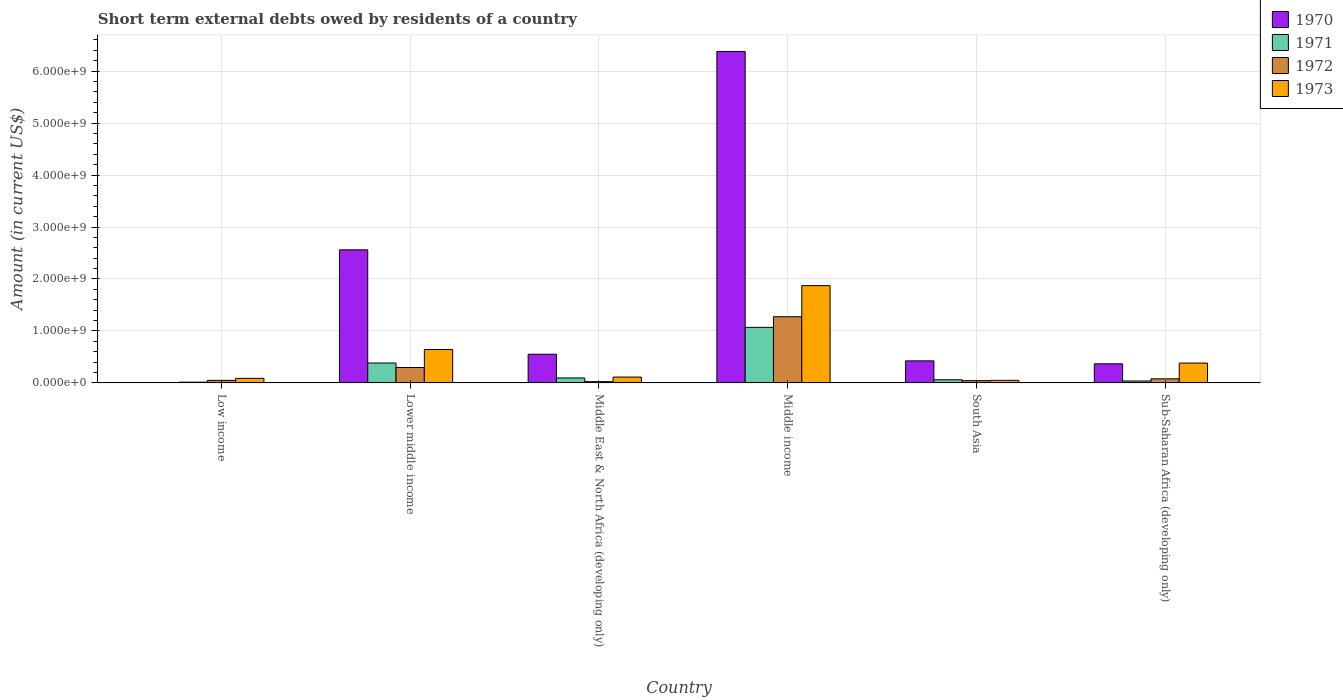How many different coloured bars are there?
Ensure brevity in your answer.  4. Are the number of bars per tick equal to the number of legend labels?
Offer a very short reply. No. What is the label of the 4th group of bars from the left?
Provide a succinct answer. Middle income. In how many cases, is the number of bars for a given country not equal to the number of legend labels?
Your response must be concise. 1. What is the amount of short-term external debts owed by residents in 1971 in South Asia?
Your answer should be compact. 6.10e+07. Across all countries, what is the maximum amount of short-term external debts owed by residents in 1972?
Make the answer very short. 1.27e+09. In which country was the amount of short-term external debts owed by residents in 1971 maximum?
Your answer should be compact. Middle income. What is the total amount of short-term external debts owed by residents in 1972 in the graph?
Give a very brief answer. 1.77e+09. What is the difference between the amount of short-term external debts owed by residents in 1972 in Lower middle income and that in Middle income?
Offer a terse response. -9.77e+08. What is the difference between the amount of short-term external debts owed by residents in 1971 in South Asia and the amount of short-term external debts owed by residents in 1972 in Lower middle income?
Offer a very short reply. -2.36e+08. What is the average amount of short-term external debts owed by residents in 1970 per country?
Give a very brief answer. 1.71e+09. What is the difference between the amount of short-term external debts owed by residents of/in 1972 and amount of short-term external debts owed by residents of/in 1970 in Middle income?
Give a very brief answer. -5.10e+09. What is the ratio of the amount of short-term external debts owed by residents in 1972 in Low income to that in Sub-Saharan Africa (developing only)?
Your answer should be very brief. 0.62. Is the difference between the amount of short-term external debts owed by residents in 1972 in Middle East & North Africa (developing only) and South Asia greater than the difference between the amount of short-term external debts owed by residents in 1970 in Middle East & North Africa (developing only) and South Asia?
Keep it short and to the point. No. What is the difference between the highest and the second highest amount of short-term external debts owed by residents in 1970?
Offer a terse response. 5.83e+09. What is the difference between the highest and the lowest amount of short-term external debts owed by residents in 1970?
Offer a very short reply. 6.38e+09. In how many countries, is the amount of short-term external debts owed by residents in 1970 greater than the average amount of short-term external debts owed by residents in 1970 taken over all countries?
Your response must be concise. 2. Is the sum of the amount of short-term external debts owed by residents in 1972 in Low income and Lower middle income greater than the maximum amount of short-term external debts owed by residents in 1973 across all countries?
Make the answer very short. No. Is it the case that in every country, the sum of the amount of short-term external debts owed by residents in 1970 and amount of short-term external debts owed by residents in 1973 is greater than the sum of amount of short-term external debts owed by residents in 1971 and amount of short-term external debts owed by residents in 1972?
Your answer should be very brief. No. How many bars are there?
Your answer should be very brief. 23. Are all the bars in the graph horizontal?
Make the answer very short. No. How many countries are there in the graph?
Your response must be concise. 6. What is the difference between two consecutive major ticks on the Y-axis?
Keep it short and to the point. 1.00e+09. Does the graph contain any zero values?
Offer a very short reply. Yes. Does the graph contain grids?
Provide a short and direct response. Yes. What is the title of the graph?
Provide a short and direct response. Short term external debts owed by residents of a country. Does "1961" appear as one of the legend labels in the graph?
Offer a very short reply. No. What is the Amount (in current US$) of 1971 in Low income?
Give a very brief answer. 1.54e+07. What is the Amount (in current US$) in 1972 in Low income?
Your response must be concise. 4.94e+07. What is the Amount (in current US$) in 1973 in Low income?
Keep it short and to the point. 8.84e+07. What is the Amount (in current US$) in 1970 in Lower middle income?
Ensure brevity in your answer.  2.56e+09. What is the Amount (in current US$) in 1971 in Lower middle income?
Your response must be concise. 3.83e+08. What is the Amount (in current US$) in 1972 in Lower middle income?
Keep it short and to the point. 2.97e+08. What is the Amount (in current US$) of 1973 in Lower middle income?
Ensure brevity in your answer.  6.43e+08. What is the Amount (in current US$) of 1970 in Middle East & North Africa (developing only)?
Give a very brief answer. 5.52e+08. What is the Amount (in current US$) in 1971 in Middle East & North Africa (developing only)?
Offer a terse response. 9.60e+07. What is the Amount (in current US$) in 1972 in Middle East & North Africa (developing only)?
Offer a terse response. 2.50e+07. What is the Amount (in current US$) of 1973 in Middle East & North Africa (developing only)?
Provide a succinct answer. 1.13e+08. What is the Amount (in current US$) of 1970 in Middle income?
Make the answer very short. 6.38e+09. What is the Amount (in current US$) in 1971 in Middle income?
Your answer should be very brief. 1.07e+09. What is the Amount (in current US$) of 1972 in Middle income?
Provide a succinct answer. 1.27e+09. What is the Amount (in current US$) of 1973 in Middle income?
Ensure brevity in your answer.  1.87e+09. What is the Amount (in current US$) in 1970 in South Asia?
Give a very brief answer. 4.25e+08. What is the Amount (in current US$) of 1971 in South Asia?
Ensure brevity in your answer.  6.10e+07. What is the Amount (in current US$) of 1972 in South Asia?
Your response must be concise. 4.40e+07. What is the Amount (in current US$) in 1970 in Sub-Saharan Africa (developing only)?
Ensure brevity in your answer.  3.68e+08. What is the Amount (in current US$) in 1971 in Sub-Saharan Africa (developing only)?
Your response must be concise. 3.78e+07. What is the Amount (in current US$) in 1972 in Sub-Saharan Africa (developing only)?
Provide a short and direct response. 7.93e+07. What is the Amount (in current US$) of 1973 in Sub-Saharan Africa (developing only)?
Offer a terse response. 3.82e+08. Across all countries, what is the maximum Amount (in current US$) of 1970?
Ensure brevity in your answer.  6.38e+09. Across all countries, what is the maximum Amount (in current US$) in 1971?
Keep it short and to the point. 1.07e+09. Across all countries, what is the maximum Amount (in current US$) in 1972?
Ensure brevity in your answer.  1.27e+09. Across all countries, what is the maximum Amount (in current US$) in 1973?
Give a very brief answer. 1.87e+09. Across all countries, what is the minimum Amount (in current US$) of 1971?
Your answer should be compact. 1.54e+07. Across all countries, what is the minimum Amount (in current US$) of 1972?
Your answer should be compact. 2.50e+07. Across all countries, what is the minimum Amount (in current US$) of 1973?
Keep it short and to the point. 5.00e+07. What is the total Amount (in current US$) in 1970 in the graph?
Your answer should be very brief. 1.03e+1. What is the total Amount (in current US$) of 1971 in the graph?
Make the answer very short. 1.66e+09. What is the total Amount (in current US$) of 1972 in the graph?
Ensure brevity in your answer.  1.77e+09. What is the total Amount (in current US$) of 1973 in the graph?
Provide a short and direct response. 3.15e+09. What is the difference between the Amount (in current US$) in 1971 in Low income and that in Lower middle income?
Your response must be concise. -3.68e+08. What is the difference between the Amount (in current US$) in 1972 in Low income and that in Lower middle income?
Ensure brevity in your answer.  -2.47e+08. What is the difference between the Amount (in current US$) in 1973 in Low income and that in Lower middle income?
Your response must be concise. -5.54e+08. What is the difference between the Amount (in current US$) in 1971 in Low income and that in Middle East & North Africa (developing only)?
Your answer should be very brief. -8.06e+07. What is the difference between the Amount (in current US$) in 1972 in Low income and that in Middle East & North Africa (developing only)?
Your answer should be compact. 2.44e+07. What is the difference between the Amount (in current US$) in 1973 in Low income and that in Middle East & North Africa (developing only)?
Provide a short and direct response. -2.46e+07. What is the difference between the Amount (in current US$) in 1971 in Low income and that in Middle income?
Your answer should be very brief. -1.05e+09. What is the difference between the Amount (in current US$) of 1972 in Low income and that in Middle income?
Make the answer very short. -1.22e+09. What is the difference between the Amount (in current US$) of 1973 in Low income and that in Middle income?
Your answer should be compact. -1.78e+09. What is the difference between the Amount (in current US$) in 1971 in Low income and that in South Asia?
Make the answer very short. -4.56e+07. What is the difference between the Amount (in current US$) of 1972 in Low income and that in South Asia?
Make the answer very short. 5.35e+06. What is the difference between the Amount (in current US$) of 1973 in Low income and that in South Asia?
Provide a succinct answer. 3.84e+07. What is the difference between the Amount (in current US$) of 1971 in Low income and that in Sub-Saharan Africa (developing only)?
Keep it short and to the point. -2.25e+07. What is the difference between the Amount (in current US$) of 1972 in Low income and that in Sub-Saharan Africa (developing only)?
Provide a short and direct response. -3.00e+07. What is the difference between the Amount (in current US$) in 1973 in Low income and that in Sub-Saharan Africa (developing only)?
Your answer should be compact. -2.94e+08. What is the difference between the Amount (in current US$) in 1970 in Lower middle income and that in Middle East & North Africa (developing only)?
Offer a terse response. 2.01e+09. What is the difference between the Amount (in current US$) in 1971 in Lower middle income and that in Middle East & North Africa (developing only)?
Make the answer very short. 2.87e+08. What is the difference between the Amount (in current US$) of 1972 in Lower middle income and that in Middle East & North Africa (developing only)?
Keep it short and to the point. 2.72e+08. What is the difference between the Amount (in current US$) in 1973 in Lower middle income and that in Middle East & North Africa (developing only)?
Your response must be concise. 5.30e+08. What is the difference between the Amount (in current US$) in 1970 in Lower middle income and that in Middle income?
Offer a very short reply. -3.82e+09. What is the difference between the Amount (in current US$) of 1971 in Lower middle income and that in Middle income?
Ensure brevity in your answer.  -6.86e+08. What is the difference between the Amount (in current US$) in 1972 in Lower middle income and that in Middle income?
Provide a succinct answer. -9.77e+08. What is the difference between the Amount (in current US$) in 1973 in Lower middle income and that in Middle income?
Keep it short and to the point. -1.23e+09. What is the difference between the Amount (in current US$) of 1970 in Lower middle income and that in South Asia?
Your answer should be very brief. 2.14e+09. What is the difference between the Amount (in current US$) of 1971 in Lower middle income and that in South Asia?
Keep it short and to the point. 3.22e+08. What is the difference between the Amount (in current US$) in 1972 in Lower middle income and that in South Asia?
Your response must be concise. 2.53e+08. What is the difference between the Amount (in current US$) of 1973 in Lower middle income and that in South Asia?
Give a very brief answer. 5.93e+08. What is the difference between the Amount (in current US$) in 1970 in Lower middle income and that in Sub-Saharan Africa (developing only)?
Make the answer very short. 2.19e+09. What is the difference between the Amount (in current US$) of 1971 in Lower middle income and that in Sub-Saharan Africa (developing only)?
Give a very brief answer. 3.46e+08. What is the difference between the Amount (in current US$) of 1972 in Lower middle income and that in Sub-Saharan Africa (developing only)?
Your answer should be very brief. 2.18e+08. What is the difference between the Amount (in current US$) in 1973 in Lower middle income and that in Sub-Saharan Africa (developing only)?
Ensure brevity in your answer.  2.61e+08. What is the difference between the Amount (in current US$) of 1970 in Middle East & North Africa (developing only) and that in Middle income?
Offer a very short reply. -5.83e+09. What is the difference between the Amount (in current US$) of 1971 in Middle East & North Africa (developing only) and that in Middle income?
Make the answer very short. -9.73e+08. What is the difference between the Amount (in current US$) in 1972 in Middle East & North Africa (developing only) and that in Middle income?
Provide a succinct answer. -1.25e+09. What is the difference between the Amount (in current US$) in 1973 in Middle East & North Africa (developing only) and that in Middle income?
Your answer should be compact. -1.76e+09. What is the difference between the Amount (in current US$) in 1970 in Middle East & North Africa (developing only) and that in South Asia?
Provide a succinct answer. 1.27e+08. What is the difference between the Amount (in current US$) of 1971 in Middle East & North Africa (developing only) and that in South Asia?
Ensure brevity in your answer.  3.50e+07. What is the difference between the Amount (in current US$) of 1972 in Middle East & North Africa (developing only) and that in South Asia?
Your response must be concise. -1.90e+07. What is the difference between the Amount (in current US$) of 1973 in Middle East & North Africa (developing only) and that in South Asia?
Provide a succinct answer. 6.30e+07. What is the difference between the Amount (in current US$) of 1970 in Middle East & North Africa (developing only) and that in Sub-Saharan Africa (developing only)?
Your answer should be compact. 1.84e+08. What is the difference between the Amount (in current US$) in 1971 in Middle East & North Africa (developing only) and that in Sub-Saharan Africa (developing only)?
Your answer should be compact. 5.82e+07. What is the difference between the Amount (in current US$) of 1972 in Middle East & North Africa (developing only) and that in Sub-Saharan Africa (developing only)?
Your answer should be very brief. -5.43e+07. What is the difference between the Amount (in current US$) of 1973 in Middle East & North Africa (developing only) and that in Sub-Saharan Africa (developing only)?
Your response must be concise. -2.69e+08. What is the difference between the Amount (in current US$) in 1970 in Middle income and that in South Asia?
Offer a terse response. 5.95e+09. What is the difference between the Amount (in current US$) in 1971 in Middle income and that in South Asia?
Ensure brevity in your answer.  1.01e+09. What is the difference between the Amount (in current US$) in 1972 in Middle income and that in South Asia?
Your response must be concise. 1.23e+09. What is the difference between the Amount (in current US$) of 1973 in Middle income and that in South Asia?
Make the answer very short. 1.82e+09. What is the difference between the Amount (in current US$) in 1970 in Middle income and that in Sub-Saharan Africa (developing only)?
Offer a terse response. 6.01e+09. What is the difference between the Amount (in current US$) in 1971 in Middle income and that in Sub-Saharan Africa (developing only)?
Ensure brevity in your answer.  1.03e+09. What is the difference between the Amount (in current US$) in 1972 in Middle income and that in Sub-Saharan Africa (developing only)?
Your answer should be compact. 1.19e+09. What is the difference between the Amount (in current US$) of 1973 in Middle income and that in Sub-Saharan Africa (developing only)?
Give a very brief answer. 1.49e+09. What is the difference between the Amount (in current US$) of 1970 in South Asia and that in Sub-Saharan Africa (developing only)?
Give a very brief answer. 5.71e+07. What is the difference between the Amount (in current US$) in 1971 in South Asia and that in Sub-Saharan Africa (developing only)?
Your answer should be very brief. 2.32e+07. What is the difference between the Amount (in current US$) of 1972 in South Asia and that in Sub-Saharan Africa (developing only)?
Offer a terse response. -3.53e+07. What is the difference between the Amount (in current US$) in 1973 in South Asia and that in Sub-Saharan Africa (developing only)?
Give a very brief answer. -3.32e+08. What is the difference between the Amount (in current US$) of 1971 in Low income and the Amount (in current US$) of 1972 in Lower middle income?
Make the answer very short. -2.81e+08. What is the difference between the Amount (in current US$) in 1971 in Low income and the Amount (in current US$) in 1973 in Lower middle income?
Give a very brief answer. -6.27e+08. What is the difference between the Amount (in current US$) in 1972 in Low income and the Amount (in current US$) in 1973 in Lower middle income?
Offer a very short reply. -5.93e+08. What is the difference between the Amount (in current US$) of 1971 in Low income and the Amount (in current US$) of 1972 in Middle East & North Africa (developing only)?
Ensure brevity in your answer.  -9.65e+06. What is the difference between the Amount (in current US$) in 1971 in Low income and the Amount (in current US$) in 1973 in Middle East & North Africa (developing only)?
Your response must be concise. -9.76e+07. What is the difference between the Amount (in current US$) in 1972 in Low income and the Amount (in current US$) in 1973 in Middle East & North Africa (developing only)?
Provide a succinct answer. -6.36e+07. What is the difference between the Amount (in current US$) in 1971 in Low income and the Amount (in current US$) in 1972 in Middle income?
Provide a succinct answer. -1.26e+09. What is the difference between the Amount (in current US$) of 1971 in Low income and the Amount (in current US$) of 1973 in Middle income?
Provide a short and direct response. -1.86e+09. What is the difference between the Amount (in current US$) of 1972 in Low income and the Amount (in current US$) of 1973 in Middle income?
Your answer should be very brief. -1.82e+09. What is the difference between the Amount (in current US$) in 1971 in Low income and the Amount (in current US$) in 1972 in South Asia?
Your response must be concise. -2.86e+07. What is the difference between the Amount (in current US$) of 1971 in Low income and the Amount (in current US$) of 1973 in South Asia?
Ensure brevity in your answer.  -3.46e+07. What is the difference between the Amount (in current US$) in 1972 in Low income and the Amount (in current US$) in 1973 in South Asia?
Your response must be concise. -6.46e+05. What is the difference between the Amount (in current US$) in 1971 in Low income and the Amount (in current US$) in 1972 in Sub-Saharan Africa (developing only)?
Offer a very short reply. -6.40e+07. What is the difference between the Amount (in current US$) of 1971 in Low income and the Amount (in current US$) of 1973 in Sub-Saharan Africa (developing only)?
Your answer should be very brief. -3.67e+08. What is the difference between the Amount (in current US$) of 1972 in Low income and the Amount (in current US$) of 1973 in Sub-Saharan Africa (developing only)?
Give a very brief answer. -3.33e+08. What is the difference between the Amount (in current US$) of 1970 in Lower middle income and the Amount (in current US$) of 1971 in Middle East & North Africa (developing only)?
Keep it short and to the point. 2.46e+09. What is the difference between the Amount (in current US$) in 1970 in Lower middle income and the Amount (in current US$) in 1972 in Middle East & North Africa (developing only)?
Offer a terse response. 2.54e+09. What is the difference between the Amount (in current US$) of 1970 in Lower middle income and the Amount (in current US$) of 1973 in Middle East & North Africa (developing only)?
Make the answer very short. 2.45e+09. What is the difference between the Amount (in current US$) in 1971 in Lower middle income and the Amount (in current US$) in 1972 in Middle East & North Africa (developing only)?
Keep it short and to the point. 3.58e+08. What is the difference between the Amount (in current US$) in 1971 in Lower middle income and the Amount (in current US$) in 1973 in Middle East & North Africa (developing only)?
Offer a terse response. 2.70e+08. What is the difference between the Amount (in current US$) in 1972 in Lower middle income and the Amount (in current US$) in 1973 in Middle East & North Africa (developing only)?
Make the answer very short. 1.84e+08. What is the difference between the Amount (in current US$) in 1970 in Lower middle income and the Amount (in current US$) in 1971 in Middle income?
Make the answer very short. 1.49e+09. What is the difference between the Amount (in current US$) in 1970 in Lower middle income and the Amount (in current US$) in 1972 in Middle income?
Your answer should be very brief. 1.29e+09. What is the difference between the Amount (in current US$) of 1970 in Lower middle income and the Amount (in current US$) of 1973 in Middle income?
Provide a short and direct response. 6.89e+08. What is the difference between the Amount (in current US$) in 1971 in Lower middle income and the Amount (in current US$) in 1972 in Middle income?
Provide a succinct answer. -8.91e+08. What is the difference between the Amount (in current US$) in 1971 in Lower middle income and the Amount (in current US$) in 1973 in Middle income?
Provide a short and direct response. -1.49e+09. What is the difference between the Amount (in current US$) in 1972 in Lower middle income and the Amount (in current US$) in 1973 in Middle income?
Keep it short and to the point. -1.58e+09. What is the difference between the Amount (in current US$) of 1970 in Lower middle income and the Amount (in current US$) of 1971 in South Asia?
Offer a very short reply. 2.50e+09. What is the difference between the Amount (in current US$) of 1970 in Lower middle income and the Amount (in current US$) of 1972 in South Asia?
Offer a very short reply. 2.52e+09. What is the difference between the Amount (in current US$) of 1970 in Lower middle income and the Amount (in current US$) of 1973 in South Asia?
Keep it short and to the point. 2.51e+09. What is the difference between the Amount (in current US$) in 1971 in Lower middle income and the Amount (in current US$) in 1972 in South Asia?
Provide a succinct answer. 3.39e+08. What is the difference between the Amount (in current US$) of 1971 in Lower middle income and the Amount (in current US$) of 1973 in South Asia?
Your answer should be compact. 3.33e+08. What is the difference between the Amount (in current US$) of 1972 in Lower middle income and the Amount (in current US$) of 1973 in South Asia?
Provide a succinct answer. 2.47e+08. What is the difference between the Amount (in current US$) in 1970 in Lower middle income and the Amount (in current US$) in 1971 in Sub-Saharan Africa (developing only)?
Provide a succinct answer. 2.52e+09. What is the difference between the Amount (in current US$) of 1970 in Lower middle income and the Amount (in current US$) of 1972 in Sub-Saharan Africa (developing only)?
Ensure brevity in your answer.  2.48e+09. What is the difference between the Amount (in current US$) of 1970 in Lower middle income and the Amount (in current US$) of 1973 in Sub-Saharan Africa (developing only)?
Offer a very short reply. 2.18e+09. What is the difference between the Amount (in current US$) of 1971 in Lower middle income and the Amount (in current US$) of 1972 in Sub-Saharan Africa (developing only)?
Your answer should be compact. 3.04e+08. What is the difference between the Amount (in current US$) in 1971 in Lower middle income and the Amount (in current US$) in 1973 in Sub-Saharan Africa (developing only)?
Keep it short and to the point. 1.02e+06. What is the difference between the Amount (in current US$) of 1972 in Lower middle income and the Amount (in current US$) of 1973 in Sub-Saharan Africa (developing only)?
Offer a terse response. -8.55e+07. What is the difference between the Amount (in current US$) in 1970 in Middle East & North Africa (developing only) and the Amount (in current US$) in 1971 in Middle income?
Make the answer very short. -5.17e+08. What is the difference between the Amount (in current US$) in 1970 in Middle East & North Africa (developing only) and the Amount (in current US$) in 1972 in Middle income?
Provide a succinct answer. -7.22e+08. What is the difference between the Amount (in current US$) in 1970 in Middle East & North Africa (developing only) and the Amount (in current US$) in 1973 in Middle income?
Your answer should be very brief. -1.32e+09. What is the difference between the Amount (in current US$) in 1971 in Middle East & North Africa (developing only) and the Amount (in current US$) in 1972 in Middle income?
Offer a terse response. -1.18e+09. What is the difference between the Amount (in current US$) of 1971 in Middle East & North Africa (developing only) and the Amount (in current US$) of 1973 in Middle income?
Make the answer very short. -1.78e+09. What is the difference between the Amount (in current US$) in 1972 in Middle East & North Africa (developing only) and the Amount (in current US$) in 1973 in Middle income?
Give a very brief answer. -1.85e+09. What is the difference between the Amount (in current US$) in 1970 in Middle East & North Africa (developing only) and the Amount (in current US$) in 1971 in South Asia?
Keep it short and to the point. 4.91e+08. What is the difference between the Amount (in current US$) in 1970 in Middle East & North Africa (developing only) and the Amount (in current US$) in 1972 in South Asia?
Give a very brief answer. 5.08e+08. What is the difference between the Amount (in current US$) in 1970 in Middle East & North Africa (developing only) and the Amount (in current US$) in 1973 in South Asia?
Provide a short and direct response. 5.02e+08. What is the difference between the Amount (in current US$) in 1971 in Middle East & North Africa (developing only) and the Amount (in current US$) in 1972 in South Asia?
Provide a short and direct response. 5.20e+07. What is the difference between the Amount (in current US$) of 1971 in Middle East & North Africa (developing only) and the Amount (in current US$) of 1973 in South Asia?
Offer a terse response. 4.60e+07. What is the difference between the Amount (in current US$) in 1972 in Middle East & North Africa (developing only) and the Amount (in current US$) in 1973 in South Asia?
Provide a succinct answer. -2.50e+07. What is the difference between the Amount (in current US$) in 1970 in Middle East & North Africa (developing only) and the Amount (in current US$) in 1971 in Sub-Saharan Africa (developing only)?
Provide a short and direct response. 5.14e+08. What is the difference between the Amount (in current US$) of 1970 in Middle East & North Africa (developing only) and the Amount (in current US$) of 1972 in Sub-Saharan Africa (developing only)?
Provide a short and direct response. 4.73e+08. What is the difference between the Amount (in current US$) in 1970 in Middle East & North Africa (developing only) and the Amount (in current US$) in 1973 in Sub-Saharan Africa (developing only)?
Your response must be concise. 1.70e+08. What is the difference between the Amount (in current US$) in 1971 in Middle East & North Africa (developing only) and the Amount (in current US$) in 1972 in Sub-Saharan Africa (developing only)?
Offer a terse response. 1.67e+07. What is the difference between the Amount (in current US$) of 1971 in Middle East & North Africa (developing only) and the Amount (in current US$) of 1973 in Sub-Saharan Africa (developing only)?
Offer a terse response. -2.86e+08. What is the difference between the Amount (in current US$) in 1972 in Middle East & North Africa (developing only) and the Amount (in current US$) in 1973 in Sub-Saharan Africa (developing only)?
Keep it short and to the point. -3.57e+08. What is the difference between the Amount (in current US$) in 1970 in Middle income and the Amount (in current US$) in 1971 in South Asia?
Your response must be concise. 6.32e+09. What is the difference between the Amount (in current US$) in 1970 in Middle income and the Amount (in current US$) in 1972 in South Asia?
Provide a short and direct response. 6.33e+09. What is the difference between the Amount (in current US$) in 1970 in Middle income and the Amount (in current US$) in 1973 in South Asia?
Your response must be concise. 6.33e+09. What is the difference between the Amount (in current US$) of 1971 in Middle income and the Amount (in current US$) of 1972 in South Asia?
Give a very brief answer. 1.03e+09. What is the difference between the Amount (in current US$) of 1971 in Middle income and the Amount (in current US$) of 1973 in South Asia?
Give a very brief answer. 1.02e+09. What is the difference between the Amount (in current US$) of 1972 in Middle income and the Amount (in current US$) of 1973 in South Asia?
Offer a very short reply. 1.22e+09. What is the difference between the Amount (in current US$) in 1970 in Middle income and the Amount (in current US$) in 1971 in Sub-Saharan Africa (developing only)?
Your answer should be compact. 6.34e+09. What is the difference between the Amount (in current US$) of 1970 in Middle income and the Amount (in current US$) of 1972 in Sub-Saharan Africa (developing only)?
Provide a short and direct response. 6.30e+09. What is the difference between the Amount (in current US$) in 1970 in Middle income and the Amount (in current US$) in 1973 in Sub-Saharan Africa (developing only)?
Ensure brevity in your answer.  6.00e+09. What is the difference between the Amount (in current US$) in 1971 in Middle income and the Amount (in current US$) in 1972 in Sub-Saharan Africa (developing only)?
Provide a short and direct response. 9.90e+08. What is the difference between the Amount (in current US$) of 1971 in Middle income and the Amount (in current US$) of 1973 in Sub-Saharan Africa (developing only)?
Your response must be concise. 6.87e+08. What is the difference between the Amount (in current US$) in 1972 in Middle income and the Amount (in current US$) in 1973 in Sub-Saharan Africa (developing only)?
Ensure brevity in your answer.  8.92e+08. What is the difference between the Amount (in current US$) in 1970 in South Asia and the Amount (in current US$) in 1971 in Sub-Saharan Africa (developing only)?
Your answer should be compact. 3.87e+08. What is the difference between the Amount (in current US$) of 1970 in South Asia and the Amount (in current US$) of 1972 in Sub-Saharan Africa (developing only)?
Offer a very short reply. 3.46e+08. What is the difference between the Amount (in current US$) in 1970 in South Asia and the Amount (in current US$) in 1973 in Sub-Saharan Africa (developing only)?
Your answer should be compact. 4.27e+07. What is the difference between the Amount (in current US$) of 1971 in South Asia and the Amount (in current US$) of 1972 in Sub-Saharan Africa (developing only)?
Offer a very short reply. -1.83e+07. What is the difference between the Amount (in current US$) of 1971 in South Asia and the Amount (in current US$) of 1973 in Sub-Saharan Africa (developing only)?
Make the answer very short. -3.21e+08. What is the difference between the Amount (in current US$) in 1972 in South Asia and the Amount (in current US$) in 1973 in Sub-Saharan Africa (developing only)?
Your response must be concise. -3.38e+08. What is the average Amount (in current US$) in 1970 per country?
Make the answer very short. 1.71e+09. What is the average Amount (in current US$) in 1971 per country?
Ensure brevity in your answer.  2.77e+08. What is the average Amount (in current US$) in 1972 per country?
Make the answer very short. 2.95e+08. What is the average Amount (in current US$) of 1973 per country?
Your answer should be very brief. 5.25e+08. What is the difference between the Amount (in current US$) of 1971 and Amount (in current US$) of 1972 in Low income?
Offer a terse response. -3.40e+07. What is the difference between the Amount (in current US$) in 1971 and Amount (in current US$) in 1973 in Low income?
Your answer should be very brief. -7.30e+07. What is the difference between the Amount (in current US$) in 1972 and Amount (in current US$) in 1973 in Low income?
Your answer should be compact. -3.90e+07. What is the difference between the Amount (in current US$) of 1970 and Amount (in current US$) of 1971 in Lower middle income?
Offer a very short reply. 2.18e+09. What is the difference between the Amount (in current US$) of 1970 and Amount (in current US$) of 1972 in Lower middle income?
Provide a short and direct response. 2.26e+09. What is the difference between the Amount (in current US$) of 1970 and Amount (in current US$) of 1973 in Lower middle income?
Provide a short and direct response. 1.92e+09. What is the difference between the Amount (in current US$) of 1971 and Amount (in current US$) of 1972 in Lower middle income?
Your answer should be compact. 8.65e+07. What is the difference between the Amount (in current US$) in 1971 and Amount (in current US$) in 1973 in Lower middle income?
Your answer should be very brief. -2.60e+08. What is the difference between the Amount (in current US$) in 1972 and Amount (in current US$) in 1973 in Lower middle income?
Keep it short and to the point. -3.46e+08. What is the difference between the Amount (in current US$) of 1970 and Amount (in current US$) of 1971 in Middle East & North Africa (developing only)?
Offer a very short reply. 4.56e+08. What is the difference between the Amount (in current US$) in 1970 and Amount (in current US$) in 1972 in Middle East & North Africa (developing only)?
Offer a terse response. 5.27e+08. What is the difference between the Amount (in current US$) in 1970 and Amount (in current US$) in 1973 in Middle East & North Africa (developing only)?
Ensure brevity in your answer.  4.39e+08. What is the difference between the Amount (in current US$) in 1971 and Amount (in current US$) in 1972 in Middle East & North Africa (developing only)?
Provide a succinct answer. 7.10e+07. What is the difference between the Amount (in current US$) in 1971 and Amount (in current US$) in 1973 in Middle East & North Africa (developing only)?
Make the answer very short. -1.70e+07. What is the difference between the Amount (in current US$) of 1972 and Amount (in current US$) of 1973 in Middle East & North Africa (developing only)?
Give a very brief answer. -8.80e+07. What is the difference between the Amount (in current US$) in 1970 and Amount (in current US$) in 1971 in Middle income?
Ensure brevity in your answer.  5.31e+09. What is the difference between the Amount (in current US$) of 1970 and Amount (in current US$) of 1972 in Middle income?
Your response must be concise. 5.10e+09. What is the difference between the Amount (in current US$) in 1970 and Amount (in current US$) in 1973 in Middle income?
Make the answer very short. 4.51e+09. What is the difference between the Amount (in current US$) of 1971 and Amount (in current US$) of 1972 in Middle income?
Offer a very short reply. -2.05e+08. What is the difference between the Amount (in current US$) of 1971 and Amount (in current US$) of 1973 in Middle income?
Offer a very short reply. -8.03e+08. What is the difference between the Amount (in current US$) of 1972 and Amount (in current US$) of 1973 in Middle income?
Your response must be concise. -5.98e+08. What is the difference between the Amount (in current US$) of 1970 and Amount (in current US$) of 1971 in South Asia?
Provide a succinct answer. 3.64e+08. What is the difference between the Amount (in current US$) of 1970 and Amount (in current US$) of 1972 in South Asia?
Offer a very short reply. 3.81e+08. What is the difference between the Amount (in current US$) in 1970 and Amount (in current US$) in 1973 in South Asia?
Make the answer very short. 3.75e+08. What is the difference between the Amount (in current US$) in 1971 and Amount (in current US$) in 1972 in South Asia?
Your answer should be very brief. 1.70e+07. What is the difference between the Amount (in current US$) of 1971 and Amount (in current US$) of 1973 in South Asia?
Keep it short and to the point. 1.10e+07. What is the difference between the Amount (in current US$) of 1972 and Amount (in current US$) of 1973 in South Asia?
Make the answer very short. -6.00e+06. What is the difference between the Amount (in current US$) of 1970 and Amount (in current US$) of 1971 in Sub-Saharan Africa (developing only)?
Provide a short and direct response. 3.30e+08. What is the difference between the Amount (in current US$) of 1970 and Amount (in current US$) of 1972 in Sub-Saharan Africa (developing only)?
Ensure brevity in your answer.  2.89e+08. What is the difference between the Amount (in current US$) of 1970 and Amount (in current US$) of 1973 in Sub-Saharan Africa (developing only)?
Offer a very short reply. -1.44e+07. What is the difference between the Amount (in current US$) of 1971 and Amount (in current US$) of 1972 in Sub-Saharan Africa (developing only)?
Your answer should be very brief. -4.15e+07. What is the difference between the Amount (in current US$) of 1971 and Amount (in current US$) of 1973 in Sub-Saharan Africa (developing only)?
Ensure brevity in your answer.  -3.45e+08. What is the difference between the Amount (in current US$) in 1972 and Amount (in current US$) in 1973 in Sub-Saharan Africa (developing only)?
Offer a very short reply. -3.03e+08. What is the ratio of the Amount (in current US$) of 1971 in Low income to that in Lower middle income?
Provide a succinct answer. 0.04. What is the ratio of the Amount (in current US$) of 1972 in Low income to that in Lower middle income?
Give a very brief answer. 0.17. What is the ratio of the Amount (in current US$) of 1973 in Low income to that in Lower middle income?
Your answer should be very brief. 0.14. What is the ratio of the Amount (in current US$) in 1971 in Low income to that in Middle East & North Africa (developing only)?
Provide a succinct answer. 0.16. What is the ratio of the Amount (in current US$) in 1972 in Low income to that in Middle East & North Africa (developing only)?
Provide a short and direct response. 1.97. What is the ratio of the Amount (in current US$) in 1973 in Low income to that in Middle East & North Africa (developing only)?
Your answer should be very brief. 0.78. What is the ratio of the Amount (in current US$) of 1971 in Low income to that in Middle income?
Keep it short and to the point. 0.01. What is the ratio of the Amount (in current US$) in 1972 in Low income to that in Middle income?
Give a very brief answer. 0.04. What is the ratio of the Amount (in current US$) in 1973 in Low income to that in Middle income?
Provide a short and direct response. 0.05. What is the ratio of the Amount (in current US$) in 1971 in Low income to that in South Asia?
Keep it short and to the point. 0.25. What is the ratio of the Amount (in current US$) in 1972 in Low income to that in South Asia?
Your answer should be very brief. 1.12. What is the ratio of the Amount (in current US$) of 1973 in Low income to that in South Asia?
Your answer should be compact. 1.77. What is the ratio of the Amount (in current US$) of 1971 in Low income to that in Sub-Saharan Africa (developing only)?
Provide a succinct answer. 0.41. What is the ratio of the Amount (in current US$) in 1972 in Low income to that in Sub-Saharan Africa (developing only)?
Your answer should be compact. 0.62. What is the ratio of the Amount (in current US$) in 1973 in Low income to that in Sub-Saharan Africa (developing only)?
Provide a succinct answer. 0.23. What is the ratio of the Amount (in current US$) of 1970 in Lower middle income to that in Middle East & North Africa (developing only)?
Offer a terse response. 4.64. What is the ratio of the Amount (in current US$) in 1971 in Lower middle income to that in Middle East & North Africa (developing only)?
Offer a terse response. 3.99. What is the ratio of the Amount (in current US$) of 1972 in Lower middle income to that in Middle East & North Africa (developing only)?
Your answer should be compact. 11.87. What is the ratio of the Amount (in current US$) of 1973 in Lower middle income to that in Middle East & North Africa (developing only)?
Your response must be concise. 5.69. What is the ratio of the Amount (in current US$) of 1970 in Lower middle income to that in Middle income?
Your answer should be very brief. 0.4. What is the ratio of the Amount (in current US$) of 1971 in Lower middle income to that in Middle income?
Offer a terse response. 0.36. What is the ratio of the Amount (in current US$) of 1972 in Lower middle income to that in Middle income?
Your response must be concise. 0.23. What is the ratio of the Amount (in current US$) in 1973 in Lower middle income to that in Middle income?
Offer a very short reply. 0.34. What is the ratio of the Amount (in current US$) in 1970 in Lower middle income to that in South Asia?
Offer a very short reply. 6.03. What is the ratio of the Amount (in current US$) of 1971 in Lower middle income to that in South Asia?
Your answer should be very brief. 6.28. What is the ratio of the Amount (in current US$) of 1972 in Lower middle income to that in South Asia?
Provide a succinct answer. 6.75. What is the ratio of the Amount (in current US$) in 1973 in Lower middle income to that in South Asia?
Offer a very short reply. 12.86. What is the ratio of the Amount (in current US$) of 1970 in Lower middle income to that in Sub-Saharan Africa (developing only)?
Offer a terse response. 6.96. What is the ratio of the Amount (in current US$) of 1971 in Lower middle income to that in Sub-Saharan Africa (developing only)?
Give a very brief answer. 10.14. What is the ratio of the Amount (in current US$) of 1972 in Lower middle income to that in Sub-Saharan Africa (developing only)?
Give a very brief answer. 3.74. What is the ratio of the Amount (in current US$) in 1973 in Lower middle income to that in Sub-Saharan Africa (developing only)?
Keep it short and to the point. 1.68. What is the ratio of the Amount (in current US$) of 1970 in Middle East & North Africa (developing only) to that in Middle income?
Your answer should be very brief. 0.09. What is the ratio of the Amount (in current US$) of 1971 in Middle East & North Africa (developing only) to that in Middle income?
Offer a terse response. 0.09. What is the ratio of the Amount (in current US$) of 1972 in Middle East & North Africa (developing only) to that in Middle income?
Your response must be concise. 0.02. What is the ratio of the Amount (in current US$) in 1973 in Middle East & North Africa (developing only) to that in Middle income?
Offer a very short reply. 0.06. What is the ratio of the Amount (in current US$) in 1970 in Middle East & North Africa (developing only) to that in South Asia?
Give a very brief answer. 1.3. What is the ratio of the Amount (in current US$) of 1971 in Middle East & North Africa (developing only) to that in South Asia?
Give a very brief answer. 1.57. What is the ratio of the Amount (in current US$) of 1972 in Middle East & North Africa (developing only) to that in South Asia?
Your response must be concise. 0.57. What is the ratio of the Amount (in current US$) in 1973 in Middle East & North Africa (developing only) to that in South Asia?
Provide a succinct answer. 2.26. What is the ratio of the Amount (in current US$) of 1970 in Middle East & North Africa (developing only) to that in Sub-Saharan Africa (developing only)?
Your answer should be compact. 1.5. What is the ratio of the Amount (in current US$) of 1971 in Middle East & North Africa (developing only) to that in Sub-Saharan Africa (developing only)?
Ensure brevity in your answer.  2.54. What is the ratio of the Amount (in current US$) of 1972 in Middle East & North Africa (developing only) to that in Sub-Saharan Africa (developing only)?
Offer a very short reply. 0.32. What is the ratio of the Amount (in current US$) of 1973 in Middle East & North Africa (developing only) to that in Sub-Saharan Africa (developing only)?
Keep it short and to the point. 0.3. What is the ratio of the Amount (in current US$) in 1970 in Middle income to that in South Asia?
Keep it short and to the point. 15.01. What is the ratio of the Amount (in current US$) of 1971 in Middle income to that in South Asia?
Your response must be concise. 17.53. What is the ratio of the Amount (in current US$) in 1972 in Middle income to that in South Asia?
Ensure brevity in your answer.  28.95. What is the ratio of the Amount (in current US$) in 1973 in Middle income to that in South Asia?
Ensure brevity in your answer.  37.44. What is the ratio of the Amount (in current US$) in 1970 in Middle income to that in Sub-Saharan Africa (developing only)?
Ensure brevity in your answer.  17.34. What is the ratio of the Amount (in current US$) in 1971 in Middle income to that in Sub-Saharan Africa (developing only)?
Keep it short and to the point. 28.29. What is the ratio of the Amount (in current US$) of 1972 in Middle income to that in Sub-Saharan Africa (developing only)?
Provide a short and direct response. 16.06. What is the ratio of the Amount (in current US$) of 1973 in Middle income to that in Sub-Saharan Africa (developing only)?
Your answer should be compact. 4.9. What is the ratio of the Amount (in current US$) of 1970 in South Asia to that in Sub-Saharan Africa (developing only)?
Your answer should be very brief. 1.16. What is the ratio of the Amount (in current US$) in 1971 in South Asia to that in Sub-Saharan Africa (developing only)?
Offer a very short reply. 1.61. What is the ratio of the Amount (in current US$) in 1972 in South Asia to that in Sub-Saharan Africa (developing only)?
Give a very brief answer. 0.55. What is the ratio of the Amount (in current US$) in 1973 in South Asia to that in Sub-Saharan Africa (developing only)?
Your answer should be compact. 0.13. What is the difference between the highest and the second highest Amount (in current US$) of 1970?
Offer a terse response. 3.82e+09. What is the difference between the highest and the second highest Amount (in current US$) of 1971?
Your answer should be very brief. 6.86e+08. What is the difference between the highest and the second highest Amount (in current US$) of 1972?
Your answer should be very brief. 9.77e+08. What is the difference between the highest and the second highest Amount (in current US$) in 1973?
Give a very brief answer. 1.23e+09. What is the difference between the highest and the lowest Amount (in current US$) in 1970?
Make the answer very short. 6.38e+09. What is the difference between the highest and the lowest Amount (in current US$) of 1971?
Your answer should be very brief. 1.05e+09. What is the difference between the highest and the lowest Amount (in current US$) of 1972?
Offer a terse response. 1.25e+09. What is the difference between the highest and the lowest Amount (in current US$) of 1973?
Your answer should be compact. 1.82e+09. 